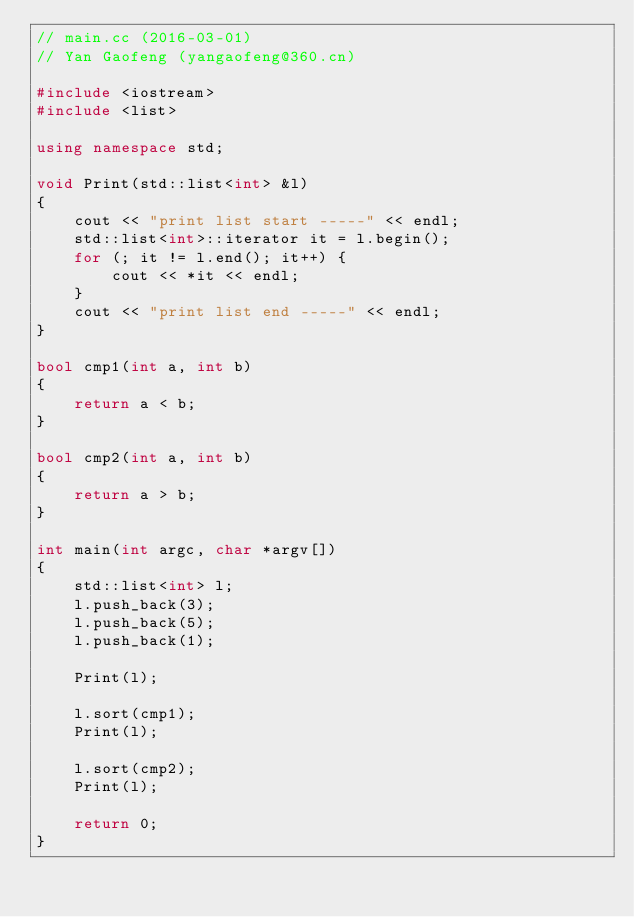<code> <loc_0><loc_0><loc_500><loc_500><_C++_>// main.cc (2016-03-01)
// Yan Gaofeng (yangaofeng@360.cn)

#include <iostream>
#include <list>

using namespace std;

void Print(std::list<int> &l)
{
    cout << "print list start -----" << endl;
    std::list<int>::iterator it = l.begin();
    for (; it != l.end(); it++) {
        cout << *it << endl;
    }
    cout << "print list end -----" << endl;
}

bool cmp1(int a, int b)
{
    return a < b;
}

bool cmp2(int a, int b)
{
    return a > b;
}

int main(int argc, char *argv[])
{
    std::list<int> l;
    l.push_back(3);
    l.push_back(5);
    l.push_back(1);

    Print(l);

    l.sort(cmp1);
    Print(l);

    l.sort(cmp2);
    Print(l);

    return 0;
}
</code> 